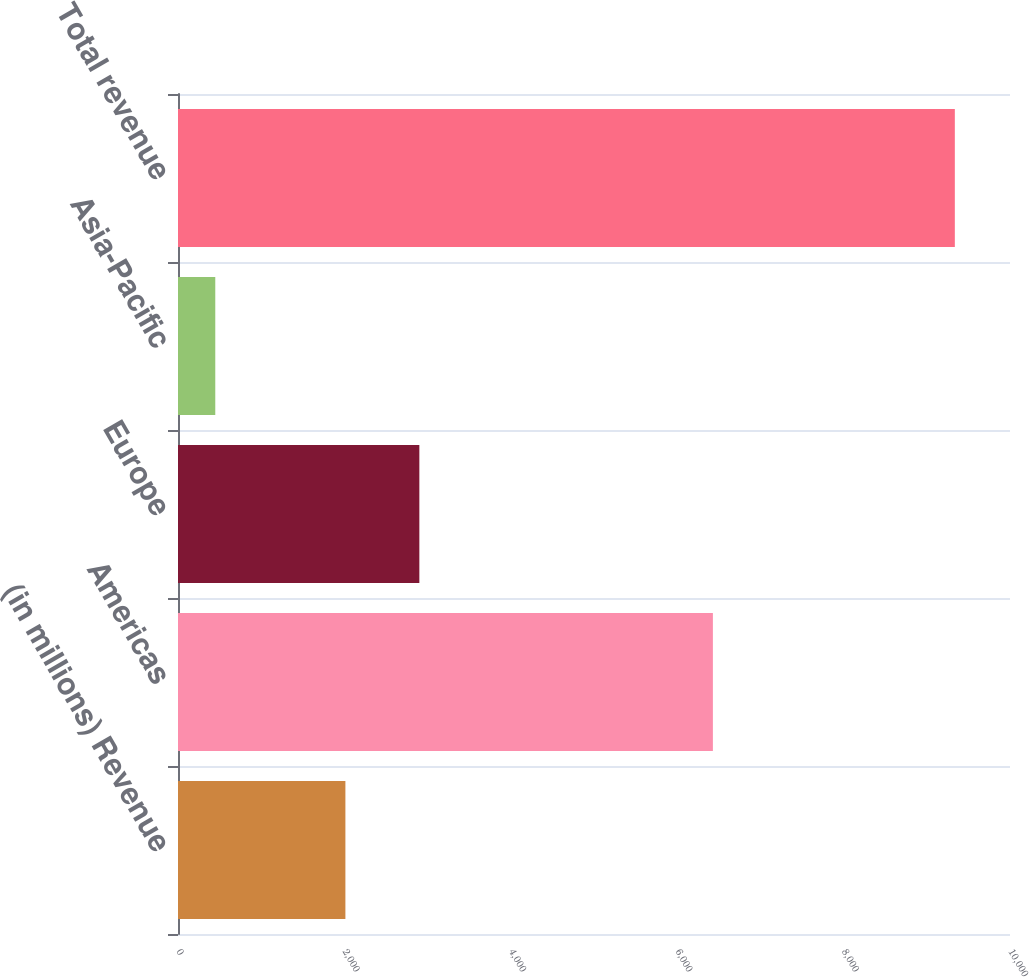Convert chart to OTSL. <chart><loc_0><loc_0><loc_500><loc_500><bar_chart><fcel>(in millions) Revenue<fcel>Americas<fcel>Europe<fcel>Asia-Pacific<fcel>Total revenue<nl><fcel>2012<fcel>6429<fcel>2900.9<fcel>448<fcel>9337<nl></chart> 